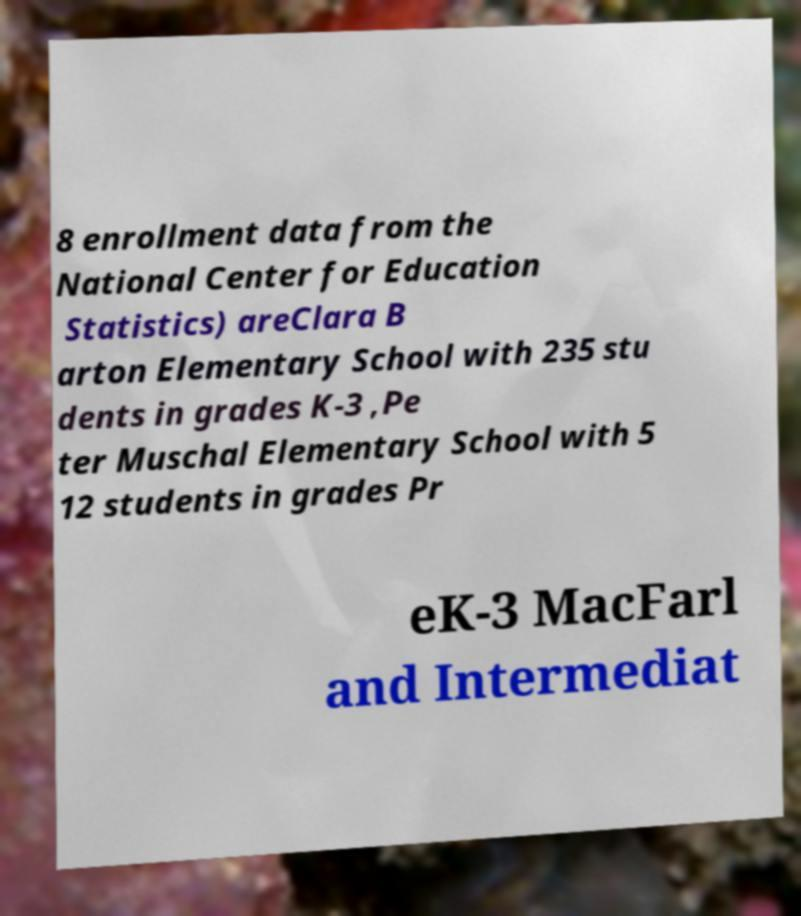What messages or text are displayed in this image? I need them in a readable, typed format. 8 enrollment data from the National Center for Education Statistics) areClara B arton Elementary School with 235 stu dents in grades K-3 ,Pe ter Muschal Elementary School with 5 12 students in grades Pr eK-3 MacFarl and Intermediat 